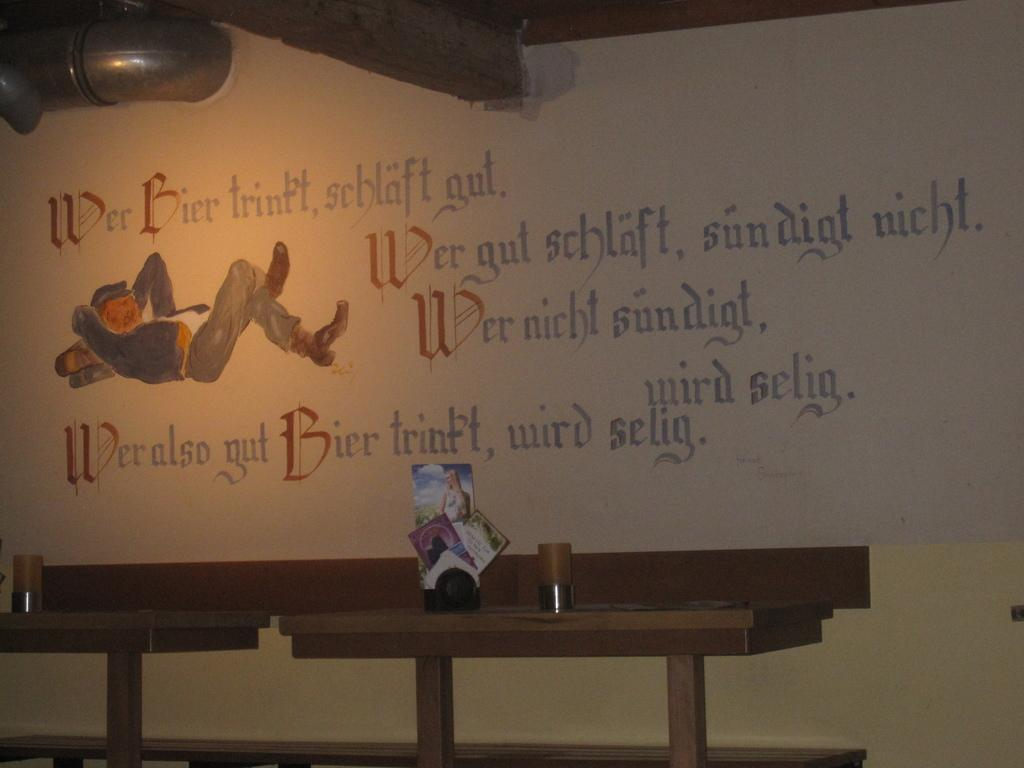<image>
Share a concise interpretation of the image provided. A mural with a man on his back relaxing has a passage that begins with "Wer Bier." 